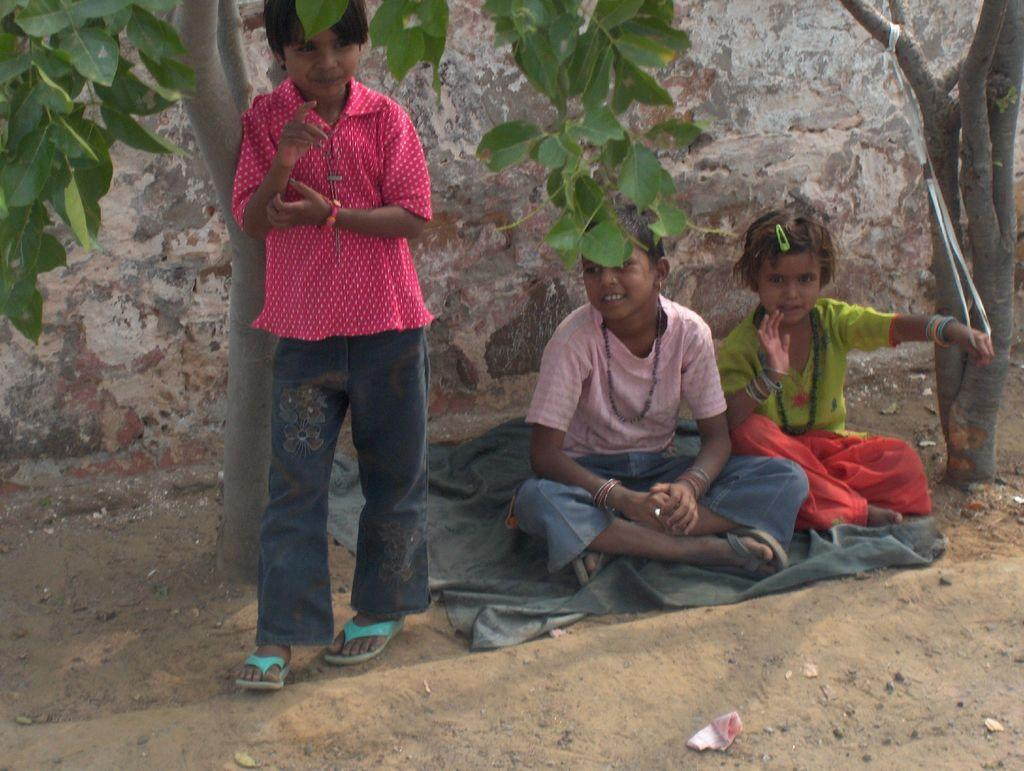Who or what can be seen in the image? There are people in the image. What are the people doing in the image? Some people are sitting on a cloth. Can you describe the object on the ground? There is an object on the ground, but its specific nature is not mentioned in the facts. What type of natural environment is visible in the image? There are trees visible in the image. What type of man-made structure is visible in the image? There is a wall in the image. What decision did the letters make in the image? There are no letters present in the image, so no decision can be made by them. 